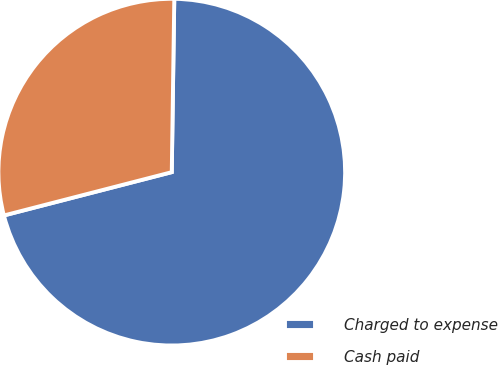<chart> <loc_0><loc_0><loc_500><loc_500><pie_chart><fcel>Charged to expense<fcel>Cash paid<nl><fcel>70.75%<fcel>29.25%<nl></chart> 